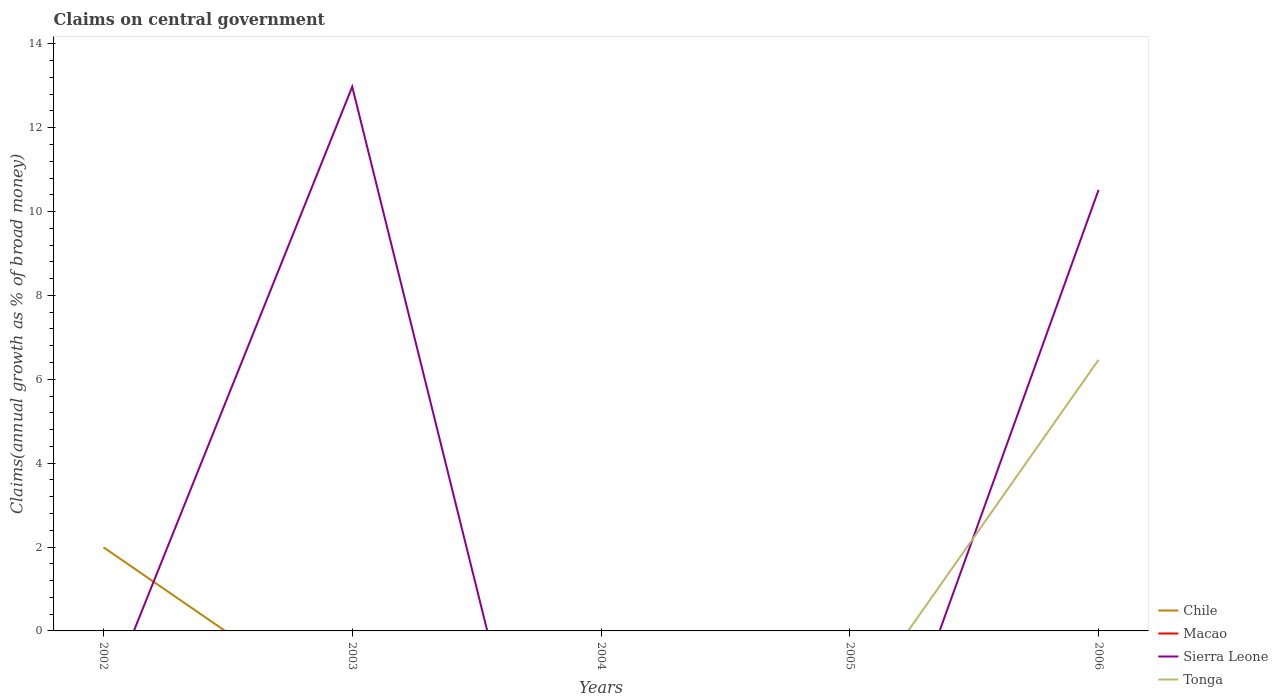Is the number of lines equal to the number of legend labels?
Offer a very short reply. No. What is the total percentage of broad money claimed on centeral government in Sierra Leone in the graph?
Your answer should be compact. 2.46. What is the difference between the highest and the second highest percentage of broad money claimed on centeral government in Tonga?
Your answer should be very brief. 6.47. Is the percentage of broad money claimed on centeral government in Tonga strictly greater than the percentage of broad money claimed on centeral government in Chile over the years?
Your response must be concise. No. How many lines are there?
Your response must be concise. 3. What is the difference between two consecutive major ticks on the Y-axis?
Your answer should be very brief. 2. How many legend labels are there?
Keep it short and to the point. 4. How are the legend labels stacked?
Ensure brevity in your answer.  Vertical. What is the title of the graph?
Your answer should be very brief. Claims on central government. Does "Fiji" appear as one of the legend labels in the graph?
Keep it short and to the point. No. What is the label or title of the Y-axis?
Provide a short and direct response. Claims(annual growth as % of broad money). What is the Claims(annual growth as % of broad money) of Chile in 2002?
Keep it short and to the point. 1.99. What is the Claims(annual growth as % of broad money) in Sierra Leone in 2002?
Your answer should be very brief. 0. What is the Claims(annual growth as % of broad money) of Tonga in 2002?
Your response must be concise. 0. What is the Claims(annual growth as % of broad money) in Sierra Leone in 2003?
Ensure brevity in your answer.  12.98. What is the Claims(annual growth as % of broad money) of Macao in 2005?
Provide a short and direct response. 0. What is the Claims(annual growth as % of broad money) of Chile in 2006?
Ensure brevity in your answer.  0. What is the Claims(annual growth as % of broad money) in Sierra Leone in 2006?
Offer a very short reply. 10.52. What is the Claims(annual growth as % of broad money) in Tonga in 2006?
Make the answer very short. 6.47. Across all years, what is the maximum Claims(annual growth as % of broad money) in Chile?
Provide a short and direct response. 1.99. Across all years, what is the maximum Claims(annual growth as % of broad money) of Sierra Leone?
Your answer should be compact. 12.98. Across all years, what is the maximum Claims(annual growth as % of broad money) of Tonga?
Your response must be concise. 6.47. Across all years, what is the minimum Claims(annual growth as % of broad money) in Chile?
Offer a terse response. 0. What is the total Claims(annual growth as % of broad money) in Chile in the graph?
Your answer should be very brief. 1.99. What is the total Claims(annual growth as % of broad money) in Macao in the graph?
Provide a succinct answer. 0. What is the total Claims(annual growth as % of broad money) of Sierra Leone in the graph?
Give a very brief answer. 23.49. What is the total Claims(annual growth as % of broad money) in Tonga in the graph?
Your answer should be very brief. 6.47. What is the difference between the Claims(annual growth as % of broad money) of Sierra Leone in 2003 and that in 2006?
Your answer should be compact. 2.46. What is the difference between the Claims(annual growth as % of broad money) in Chile in 2002 and the Claims(annual growth as % of broad money) in Sierra Leone in 2003?
Your answer should be compact. -10.98. What is the difference between the Claims(annual growth as % of broad money) in Chile in 2002 and the Claims(annual growth as % of broad money) in Sierra Leone in 2006?
Your answer should be compact. -8.52. What is the difference between the Claims(annual growth as % of broad money) in Chile in 2002 and the Claims(annual growth as % of broad money) in Tonga in 2006?
Your answer should be very brief. -4.47. What is the difference between the Claims(annual growth as % of broad money) in Sierra Leone in 2003 and the Claims(annual growth as % of broad money) in Tonga in 2006?
Provide a succinct answer. 6.51. What is the average Claims(annual growth as % of broad money) in Chile per year?
Keep it short and to the point. 0.4. What is the average Claims(annual growth as % of broad money) in Sierra Leone per year?
Make the answer very short. 4.7. What is the average Claims(annual growth as % of broad money) of Tonga per year?
Offer a terse response. 1.29. In the year 2006, what is the difference between the Claims(annual growth as % of broad money) in Sierra Leone and Claims(annual growth as % of broad money) in Tonga?
Provide a short and direct response. 4.05. What is the ratio of the Claims(annual growth as % of broad money) in Sierra Leone in 2003 to that in 2006?
Offer a very short reply. 1.23. What is the difference between the highest and the lowest Claims(annual growth as % of broad money) in Chile?
Ensure brevity in your answer.  1.99. What is the difference between the highest and the lowest Claims(annual growth as % of broad money) in Sierra Leone?
Your answer should be very brief. 12.98. What is the difference between the highest and the lowest Claims(annual growth as % of broad money) in Tonga?
Provide a succinct answer. 6.47. 